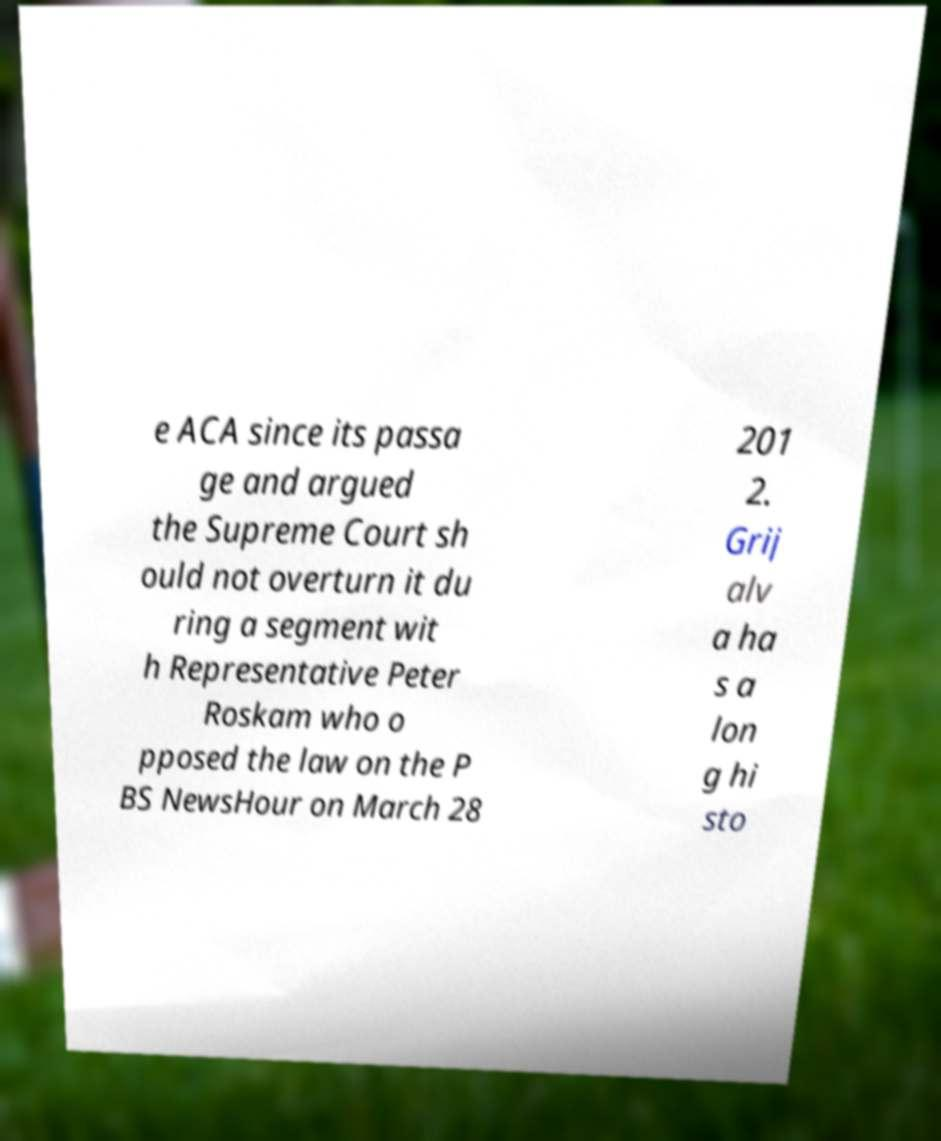For documentation purposes, I need the text within this image transcribed. Could you provide that? e ACA since its passa ge and argued the Supreme Court sh ould not overturn it du ring a segment wit h Representative Peter Roskam who o pposed the law on the P BS NewsHour on March 28 201 2. Grij alv a ha s a lon g hi sto 